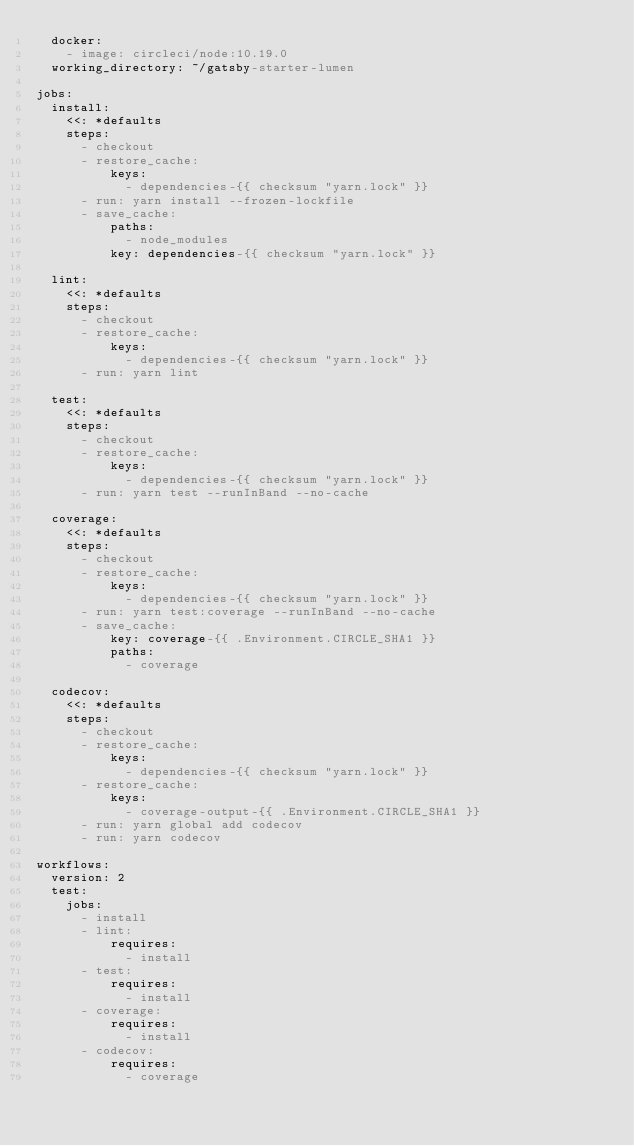Convert code to text. <code><loc_0><loc_0><loc_500><loc_500><_YAML_>  docker:
    - image: circleci/node:10.19.0
  working_directory: ~/gatsby-starter-lumen

jobs:
  install:
    <<: *defaults
    steps:
      - checkout
      - restore_cache:
          keys:
            - dependencies-{{ checksum "yarn.lock" }}
      - run: yarn install --frozen-lockfile
      - save_cache:
          paths:
            - node_modules
          key: dependencies-{{ checksum "yarn.lock" }}

  lint:
    <<: *defaults
    steps:
      - checkout
      - restore_cache:
          keys:
            - dependencies-{{ checksum "yarn.lock" }}
      - run: yarn lint

  test:
    <<: *defaults
    steps:
      - checkout
      - restore_cache:
          keys:
            - dependencies-{{ checksum "yarn.lock" }}
      - run: yarn test --runInBand --no-cache

  coverage:
    <<: *defaults
    steps:
      - checkout
      - restore_cache:
          keys:
            - dependencies-{{ checksum "yarn.lock" }}
      - run: yarn test:coverage --runInBand --no-cache
      - save_cache:
          key: coverage-{{ .Environment.CIRCLE_SHA1 }}
          paths:
            - coverage

  codecov:
    <<: *defaults
    steps:
      - checkout
      - restore_cache:
          keys:
            - dependencies-{{ checksum "yarn.lock" }}
      - restore_cache:
          keys:
            - coverage-output-{{ .Environment.CIRCLE_SHA1 }}
      - run: yarn global add codecov
      - run: yarn codecov
    
workflows:
  version: 2
  test:
    jobs:
      - install
      - lint:
          requires:
            - install
      - test:
          requires:
            - install
      - coverage:
          requires:
            - install
      - codecov:
          requires:
            - coverage</code> 